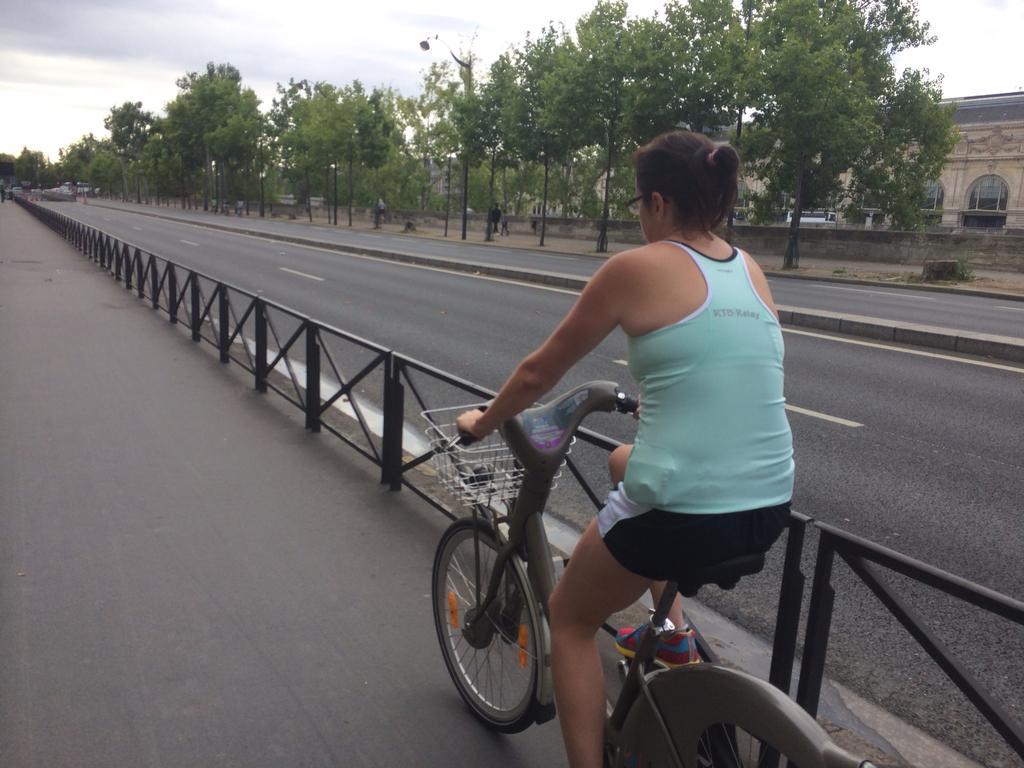Could you give a brief overview of what you see in this image? In this image, there is a person wearing colorful clothes and footwear. This person is riding a bicycle on the road. There is a sky and some trees at the top of the image. There is a building in the top right of the image. 